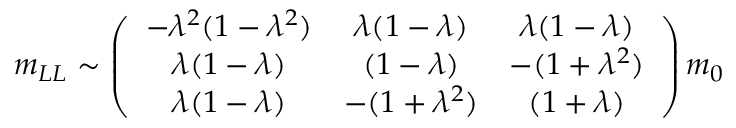Convert formula to latex. <formula><loc_0><loc_0><loc_500><loc_500>m _ { L L } \sim \left ( \begin{array} { c c c } { { - \lambda ^ { 2 } ( 1 - \lambda ^ { 2 } ) } } & { \lambda ( 1 - \lambda ) } & { \lambda ( 1 - \lambda ) } \\ { \lambda ( 1 - \lambda ) } & { ( 1 - \lambda ) } & { { - ( 1 + \lambda ^ { 2 } ) } } \\ { \lambda ( 1 - \lambda ) } & { { - ( 1 + \lambda ^ { 2 } ) } } & { ( 1 + \lambda ) } \end{array} \right ) m _ { 0 }</formula> 